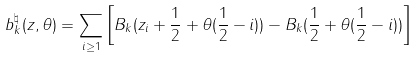<formula> <loc_0><loc_0><loc_500><loc_500>b ^ { \natural } _ { k } ( z , \theta ) = \sum _ { i \geq 1 } \left [ B _ { k } ( z _ { i } + \frac { 1 } { 2 } + \theta ( \frac { 1 } { 2 } - i ) ) - B _ { k } ( \frac { 1 } { 2 } + \theta ( \frac { 1 } { 2 } - i ) ) \right ]</formula> 